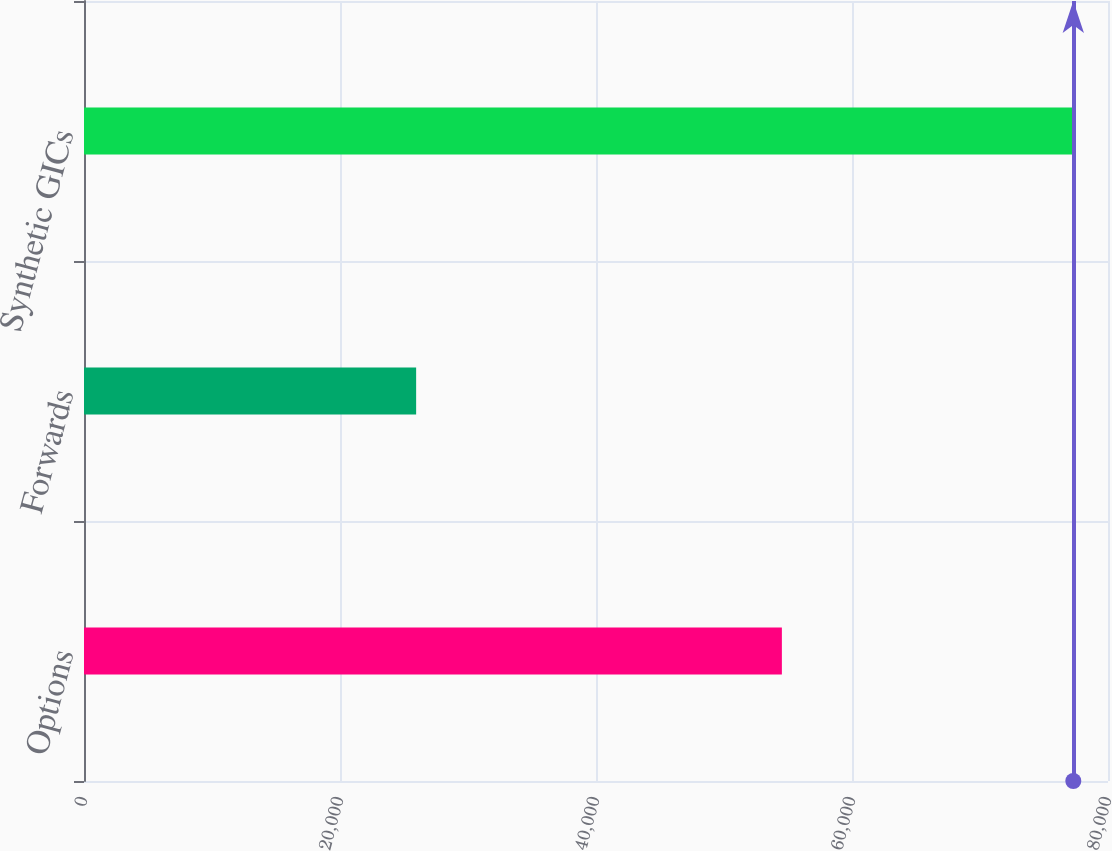Convert chart to OTSL. <chart><loc_0><loc_0><loc_500><loc_500><bar_chart><fcel>Options<fcel>Forwards<fcel>Synthetic GICs<nl><fcel>54522<fcel>25948<fcel>77290<nl></chart> 